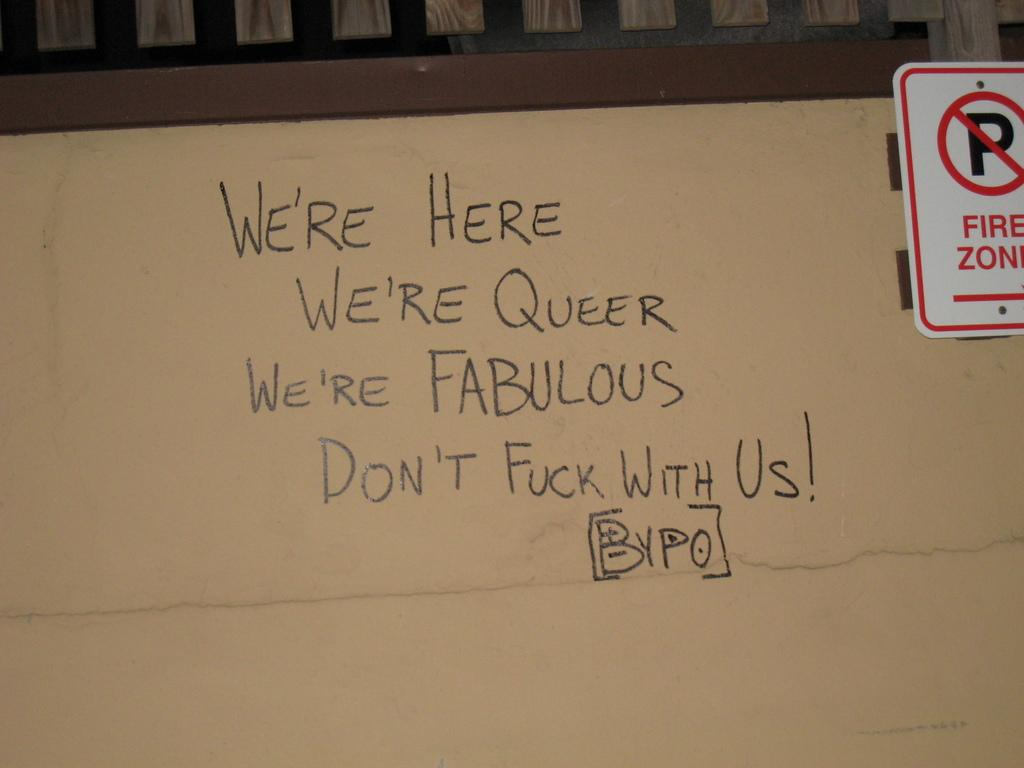<image>
Write a terse but informative summary of the picture. A white board with a quote on it that starts with, "We're here, we're queer..." 